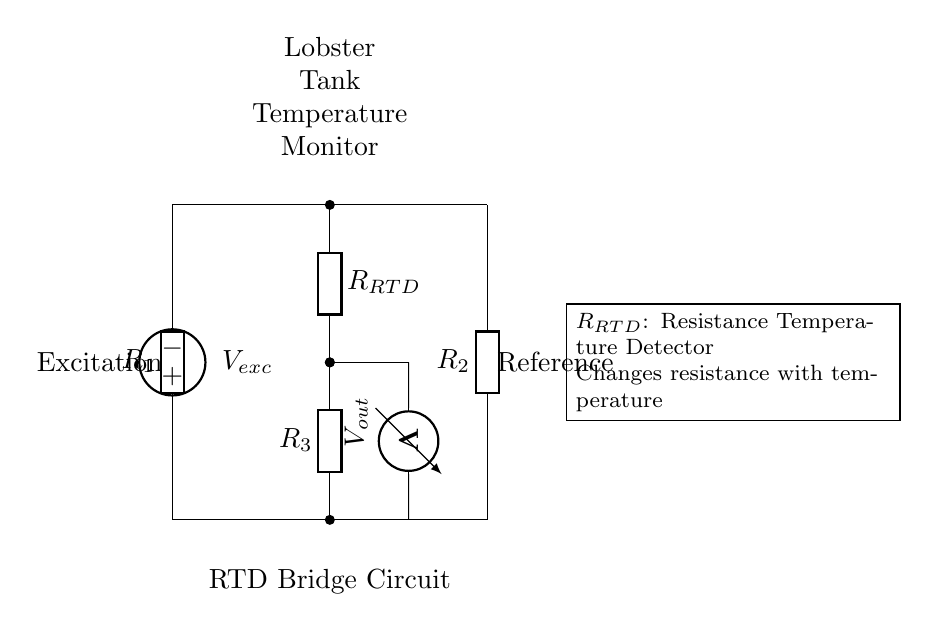What type of circuit is this? This is a bridge circuit, which is specifically designed to measure resistance variations, in this case, the resistance of the RTD in relation to temperature changes.
Answer: bridge What does R_{RTD} represent? R_{RTD} represents the Resistance Temperature Detector, which changes its resistance based on the temperature it is measuring.
Answer: Resistance Temperature Detector What is the function of V_{exc}? V_{exc} provides the excitation voltage necessary to power the bridge circuit and enable the measurement of resistance changes.
Answer: excitation voltage What is measured by the voltmeter in this circuit? The voltmeter measures the output voltage difference across the bridge circuit, which indicates any imbalance caused by resistance changes in R_{RTD}.
Answer: output voltage How many resistors are in this circuit? There are three resistors in this circuit: R_{1}, R_{2}, and R_{3}.
Answer: three What is the purpose of the bridge circuit in this application? The bridge circuit is used to ensure precise temperature monitoring in lobster tanks by accurately detecting resistance changes in the RTD.
Answer: precise temperature monitoring What happens if R_{RTD} increases? If R_{RTD} increases, it will create an imbalance in the bridge, resulting in a measurable change in output voltage across the voltmeter.
Answer: imbalance in output voltage 